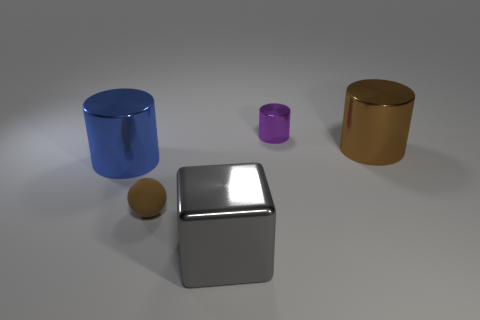What size is the gray block that is made of the same material as the brown cylinder?
Your answer should be very brief. Large. What number of brown metallic objects have the same shape as the small rubber object?
Make the answer very short. 0. What number of small cyan metallic blocks are there?
Keep it short and to the point. 0. There is a metallic object in front of the small sphere; is it the same shape as the large blue thing?
Your response must be concise. No. There is a purple cylinder that is the same size as the matte ball; what material is it?
Ensure brevity in your answer.  Metal. Is there a small brown ball that has the same material as the large brown cylinder?
Ensure brevity in your answer.  No. Do the purple metal thing and the brown thing behind the small brown ball have the same shape?
Ensure brevity in your answer.  Yes. How many things are both right of the tiny matte object and in front of the tiny purple object?
Give a very brief answer. 2. Are the small purple cylinder and the object that is in front of the sphere made of the same material?
Your answer should be compact. Yes. Is the number of large blue objects that are right of the rubber ball the same as the number of things?
Offer a terse response. No. 